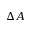<formula> <loc_0><loc_0><loc_500><loc_500>\Delta A</formula> 